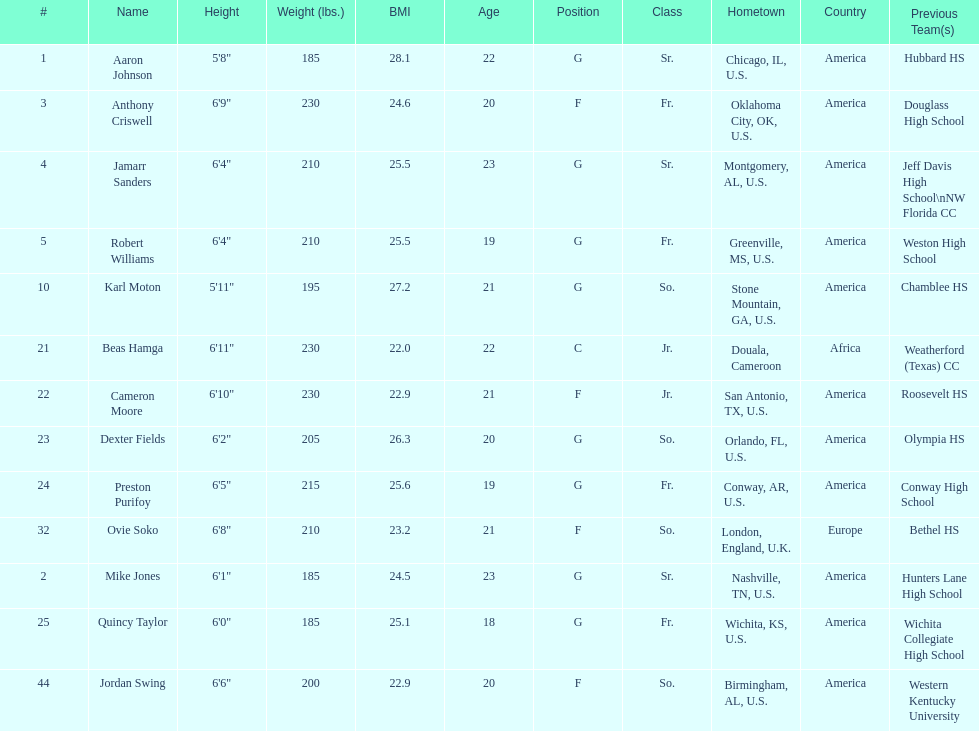What is the number of seniors on the team? 3. 